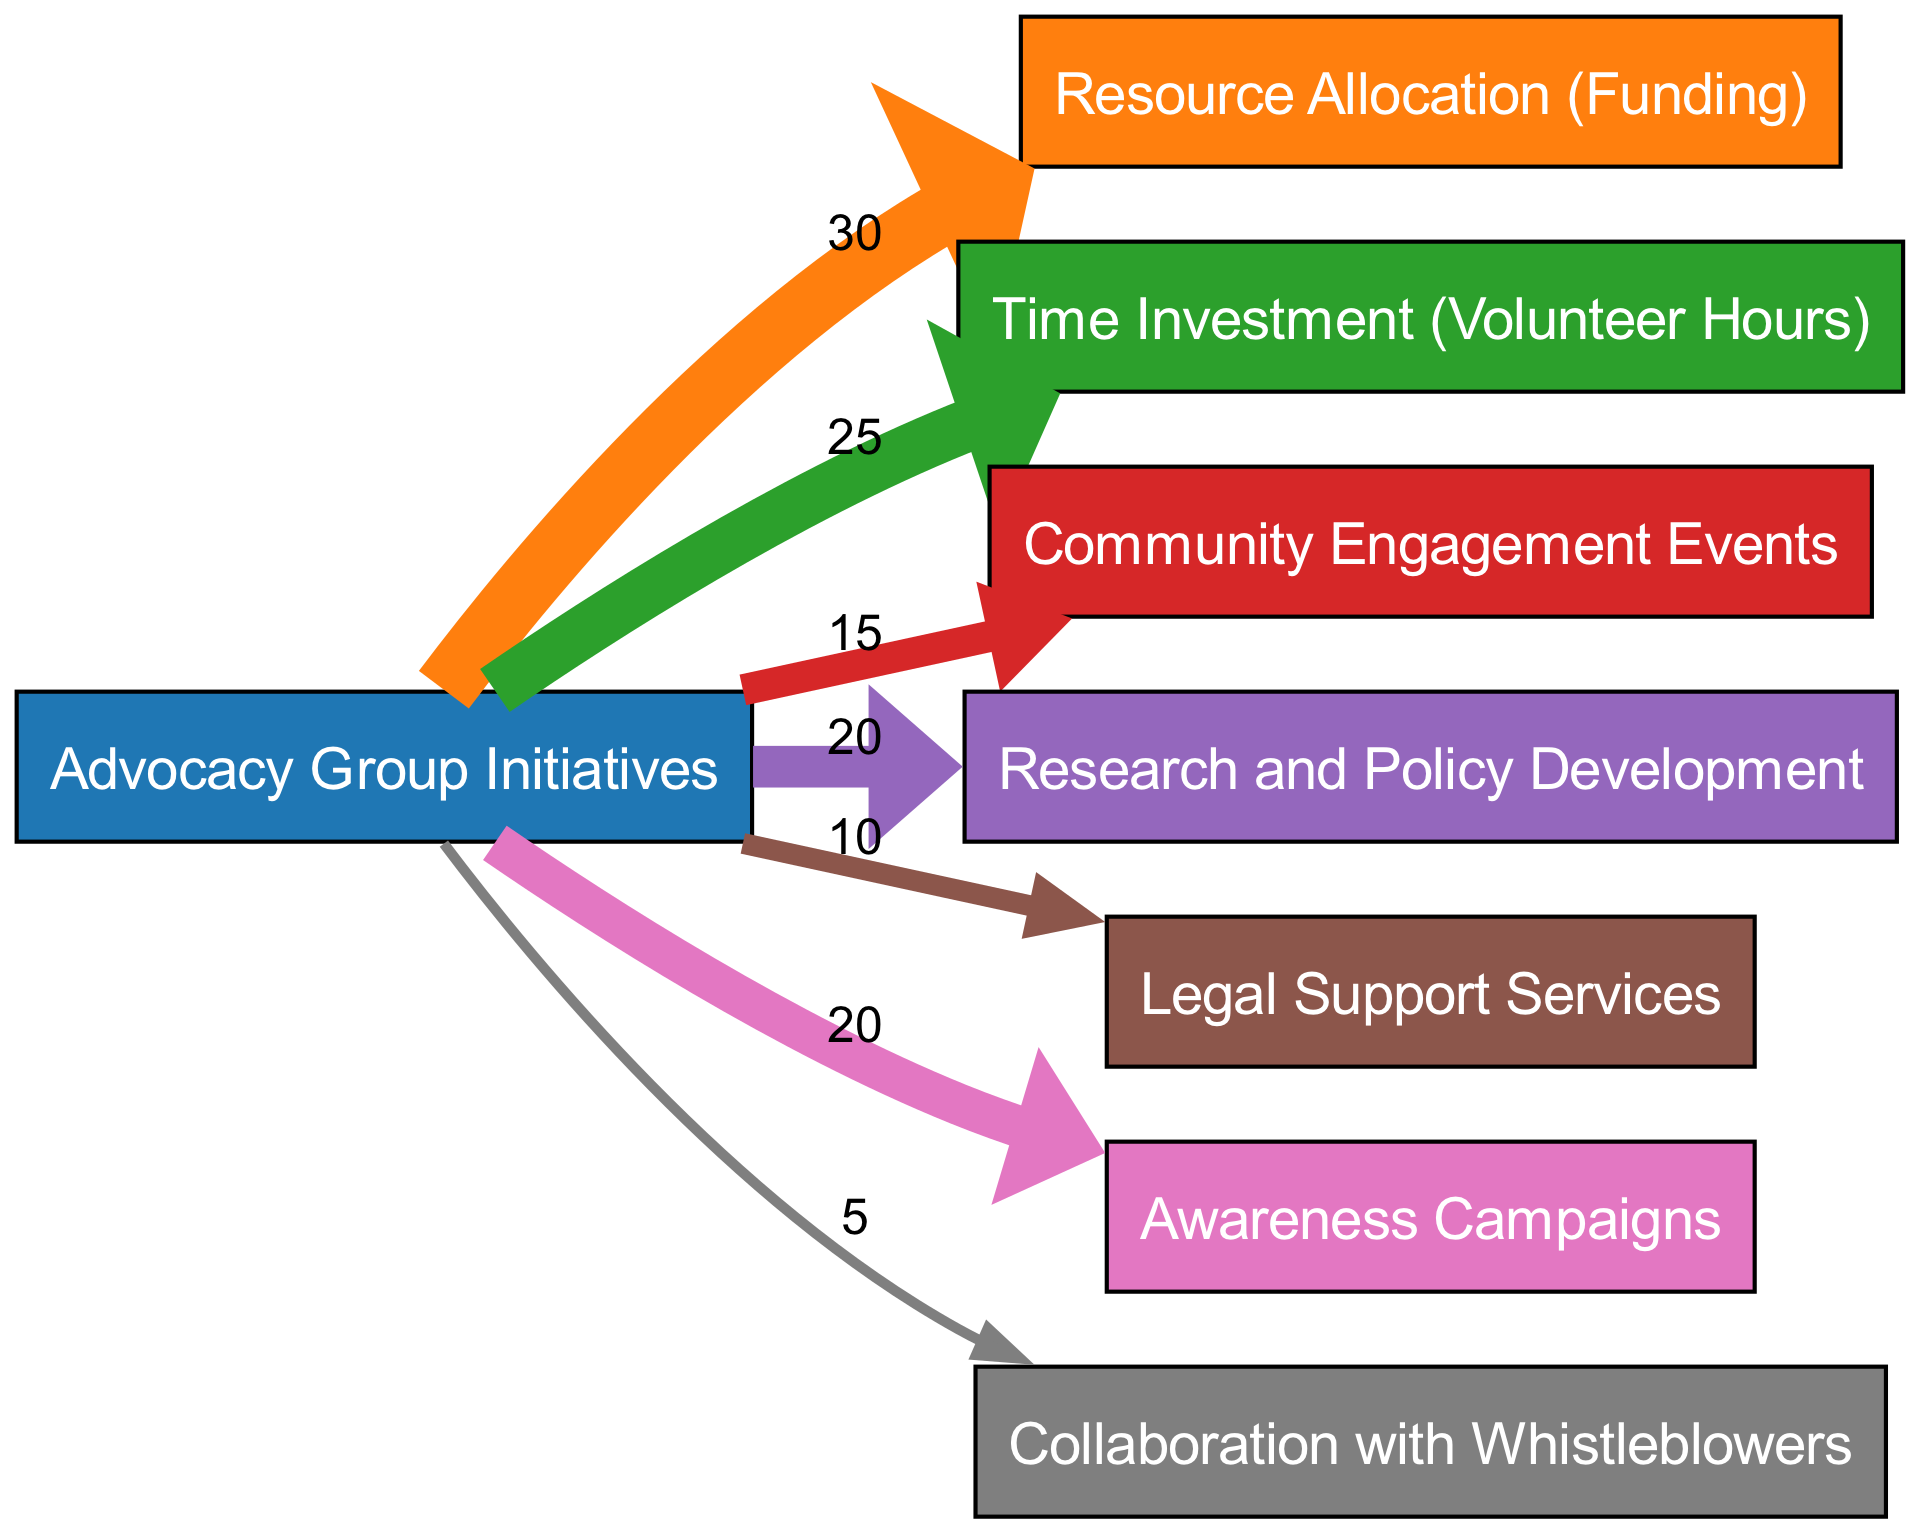What is the total number of nodes in the diagram? The diagram lists several distinct nodes, which represent different components of the advocacy group initiatives. By counting each unique name, we find there are eight nodes in total.
Answer: 8 Which target receives the most funding? By examining the links from the "Advocacy Group Initiatives" node to each target, we see "Resource Allocation (Funding)" has the highest value associated with it, which is 30.
Answer: Resource Allocation (Funding) How many volunteer hours are allocated to time investment? The "Time Investment (Volunteer Hours)" node indicates a value of 25 representing hours dedicated to advocacy activities.
Answer: 25 Which initiative has the least amount of collaboration? Looking at the values linked to "Collaboration with Whistleblowers", we see it has the lowest value of 5, indicating it receives the least collaboration effort.
Answer: Collaboration with Whistleblowers What is the total amount of resources allocated for awareness campaigns and legal support services combined? By adding the values associated with both "Awareness Campaigns" (20) and "Legal Support Services" (10), we compute the total as 20 + 10 = 30.
Answer: 30 How does the resource allocation to awareness campaigns compare to time investment? The diagram shows "Awareness Campaigns" with a value of 20 and "Time Investment (Volunteer Hours)" with a value of 25. Thus, time investment is greater than awareness campaigns by 5.
Answer: Time Investment (Volunteer Hours) What is the combined value for research and policy development and community engagement events? We find and sum the values for both nodes: "Research and Policy Development" has a value of 20 and "Community Engagement Events" has a value of 15, leading to a total of 20 + 15 = 35.
Answer: 35 Which target has a flow of exactly 15 units? From the diagram, "Community Engagement Events" specifically has a value of 15 flowing from the advocacy initiatives node.
Answer: Community Engagement Events 